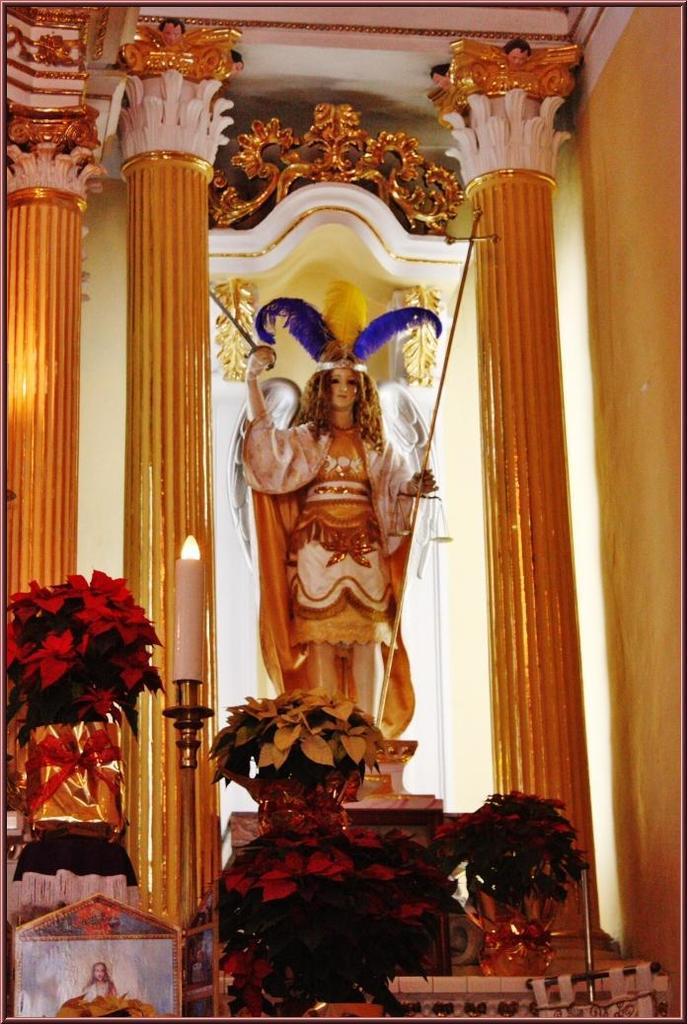What is the main subject of the image? There is a sculpture of a person in the image. What other elements can be seen in the image? There are plants, a frame, pillars, and a wall in the image. What type of quilt is draped over the sculpture in the image? There is no quilt present in the image; it features a sculpture of a person, plants, a frame, pillars, and a wall. How many cats can be seen interacting with the sculpture in the image? There are no cats present in the image. 